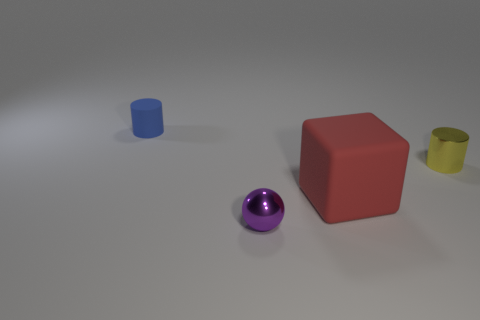Add 1 shiny cylinders. How many objects exist? 5 Subtract all blocks. How many objects are left? 3 Subtract all gray balls. Subtract all yellow cylinders. How many balls are left? 1 Subtract all cubes. Subtract all large gray metallic cylinders. How many objects are left? 3 Add 3 rubber cylinders. How many rubber cylinders are left? 4 Add 3 large green metal blocks. How many large green metal blocks exist? 3 Subtract 0 yellow spheres. How many objects are left? 4 